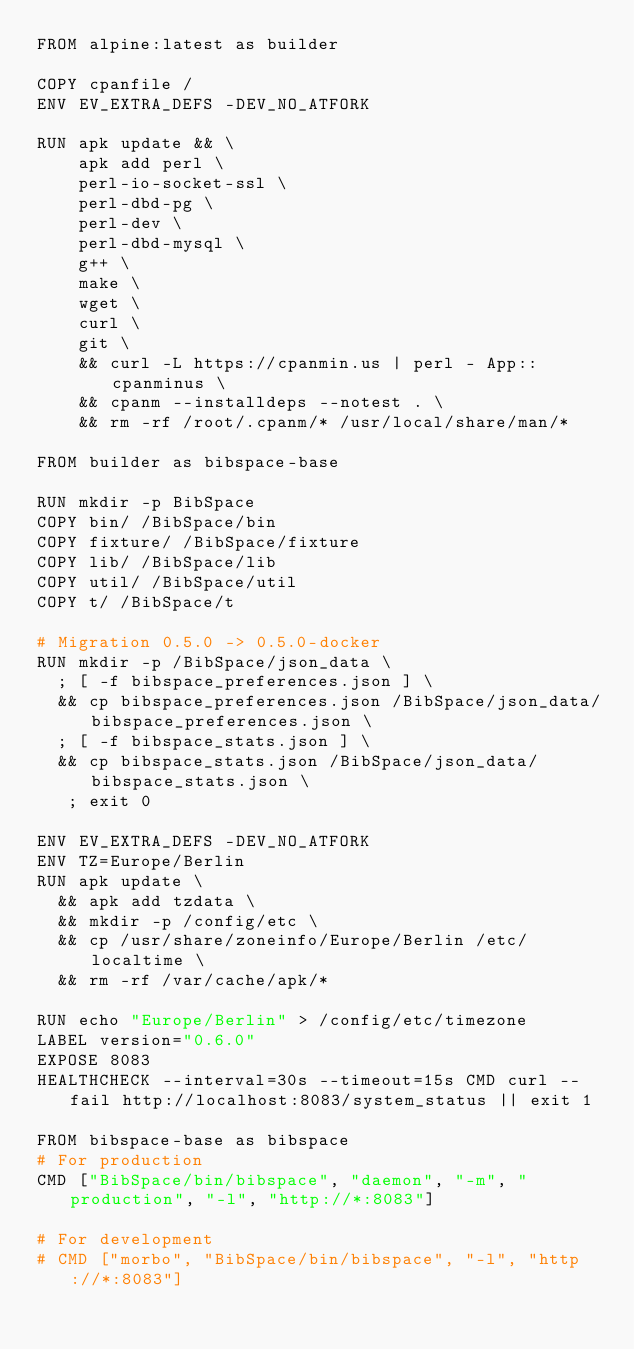Convert code to text. <code><loc_0><loc_0><loc_500><loc_500><_Dockerfile_>FROM alpine:latest as builder

COPY cpanfile /
ENV EV_EXTRA_DEFS -DEV_NO_ATFORK

RUN apk update && \
    apk add perl \
    perl-io-socket-ssl \
    perl-dbd-pg \
    perl-dev \
    perl-dbd-mysql \
    g++ \
    make \
    wget \
    curl \
    git \
    && curl -L https://cpanmin.us | perl - App::cpanminus \
    && cpanm --installdeps --notest . \
    && rm -rf /root/.cpanm/* /usr/local/share/man/*

FROM builder as bibspace-base

RUN mkdir -p BibSpace
COPY bin/ /BibSpace/bin
COPY fixture/ /BibSpace/fixture
COPY lib/ /BibSpace/lib
COPY util/ /BibSpace/util
COPY t/ /BibSpace/t

# Migration 0.5.0 -> 0.5.0-docker
RUN mkdir -p /BibSpace/json_data \
  ; [ -f bibspace_preferences.json ] \
  && cp bibspace_preferences.json /BibSpace/json_data/bibspace_preferences.json \
  ; [ -f bibspace_stats.json ] \
  && cp bibspace_stats.json /BibSpace/json_data/bibspace_stats.json \
   ; exit 0

ENV EV_EXTRA_DEFS -DEV_NO_ATFORK
ENV TZ=Europe/Berlin
RUN apk update \
  && apk add tzdata \
  && mkdir -p /config/etc \
  && cp /usr/share/zoneinfo/Europe/Berlin /etc/localtime \
  && rm -rf /var/cache/apk/*

RUN echo "Europe/Berlin" > /config/etc/timezone
LABEL version="0.6.0"
EXPOSE 8083
HEALTHCHECK --interval=30s --timeout=15s CMD curl --fail http://localhost:8083/system_status || exit 1

FROM bibspace-base as bibspace
# For production
CMD ["BibSpace/bin/bibspace", "daemon", "-m", "production", "-l", "http://*:8083"]

# For development
# CMD ["morbo", "BibSpace/bin/bibspace", "-l", "http://*:8083"]
</code> 